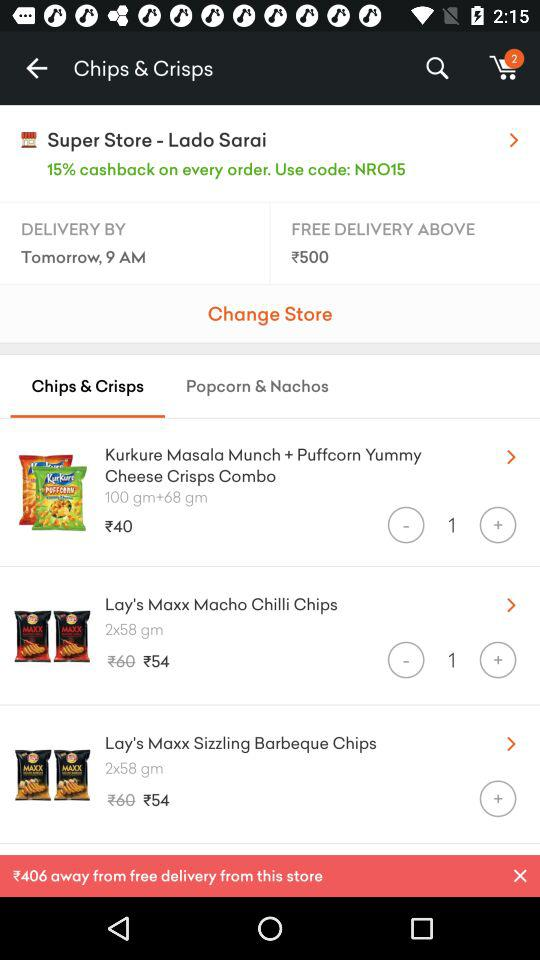How many products are in the cart? There are 2 products in the cart. 